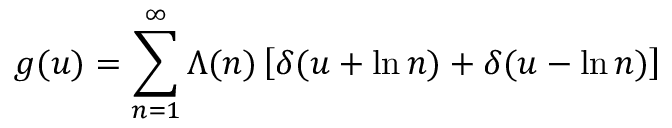Convert formula to latex. <formula><loc_0><loc_0><loc_500><loc_500>g ( u ) = \sum _ { n = 1 } ^ { \infty } \Lambda ( n ) \left [ \delta ( u + \ln n ) + \delta ( u - \ln n ) \right ]</formula> 